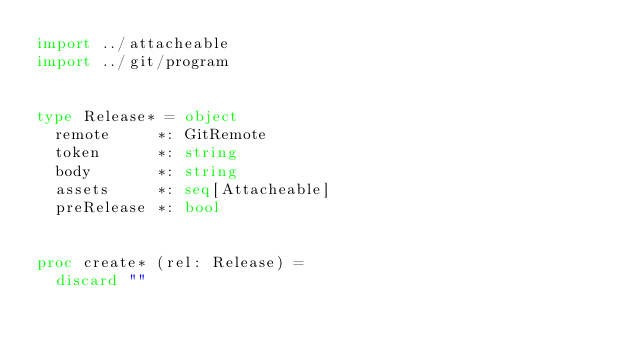Convert code to text. <code><loc_0><loc_0><loc_500><loc_500><_Nim_>import ../attacheable
import ../git/program


type Release* = object
  remote     *: GitRemote
  token      *: string
  body       *: string
  assets     *: seq[Attacheable]
  preRelease *: bool


proc create* (rel: Release) =
  discard ""
</code> 